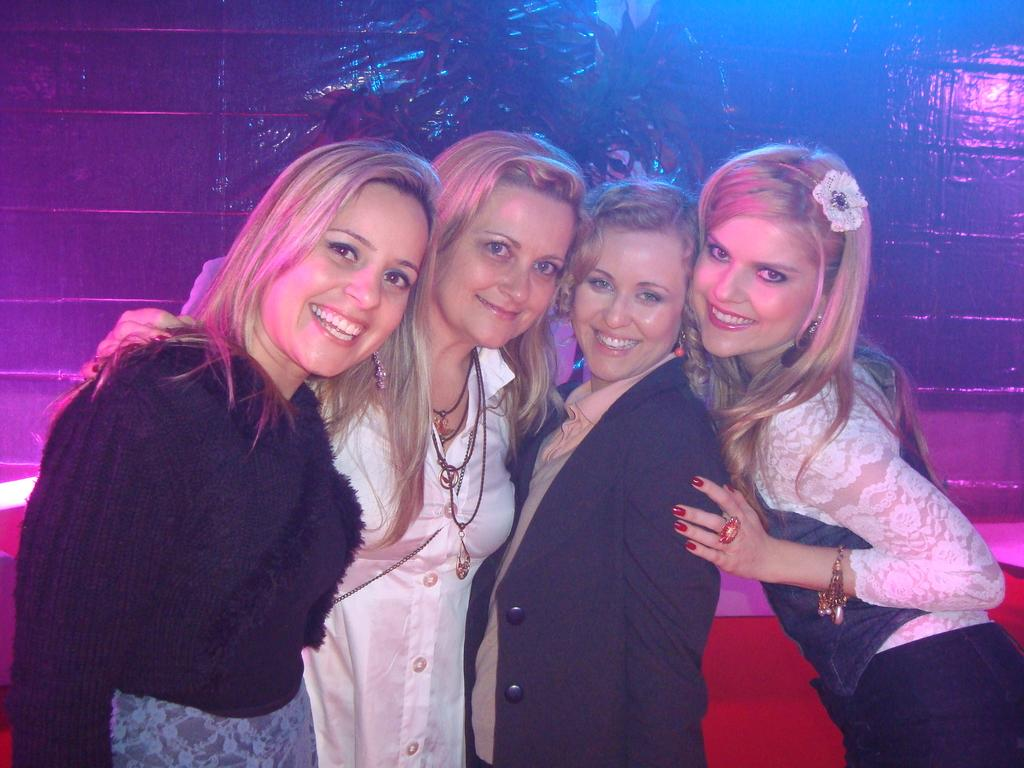How many women are in the image? There are four women standing and smiling in the image. What color is the couch in the image? There is a red couch in the image. What type of background can be seen in the image? There appears to be a wall in the image. What type of butter is being used by the women in the image? There is no butter present in the image; the women are simply standing and smiling. 